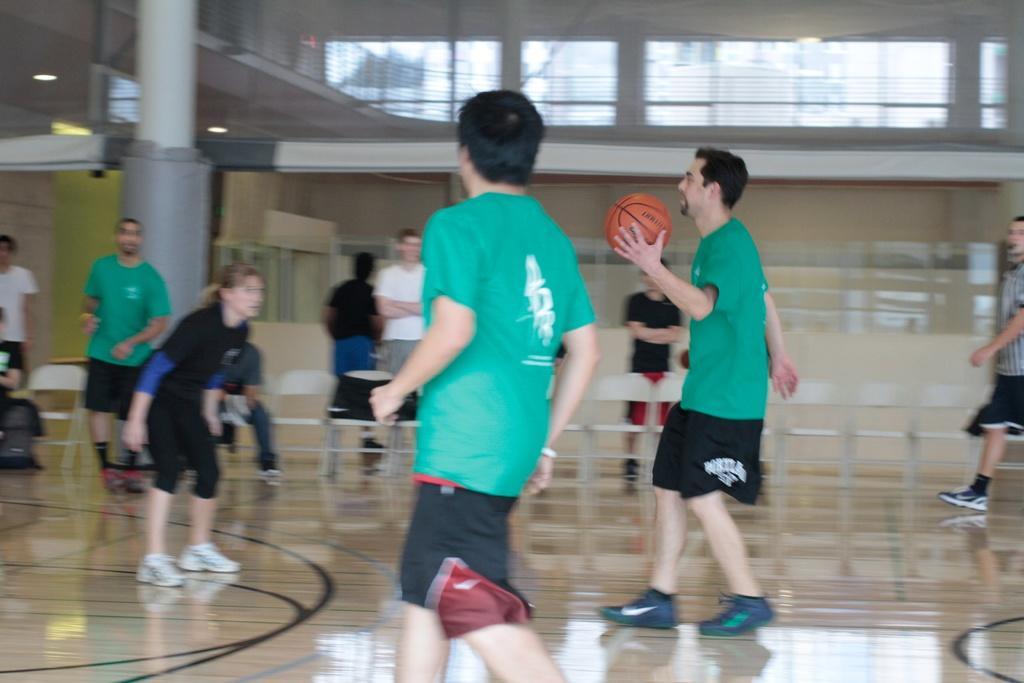In one or two sentences, can you explain what this image depicts? In this image there are people playing on the floor. The man in the center is holding a basketball in his hand. Behind them there are chairs. There are bags and a person sitting on the chairs. In the background there is a wall of the building. There are glass windows to the walls of the building. There are lights to the ceiling. 